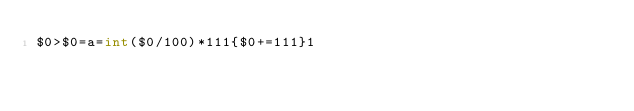Convert code to text. <code><loc_0><loc_0><loc_500><loc_500><_Awk_>$0>$0=a=int($0/100)*111{$0+=111}1</code> 